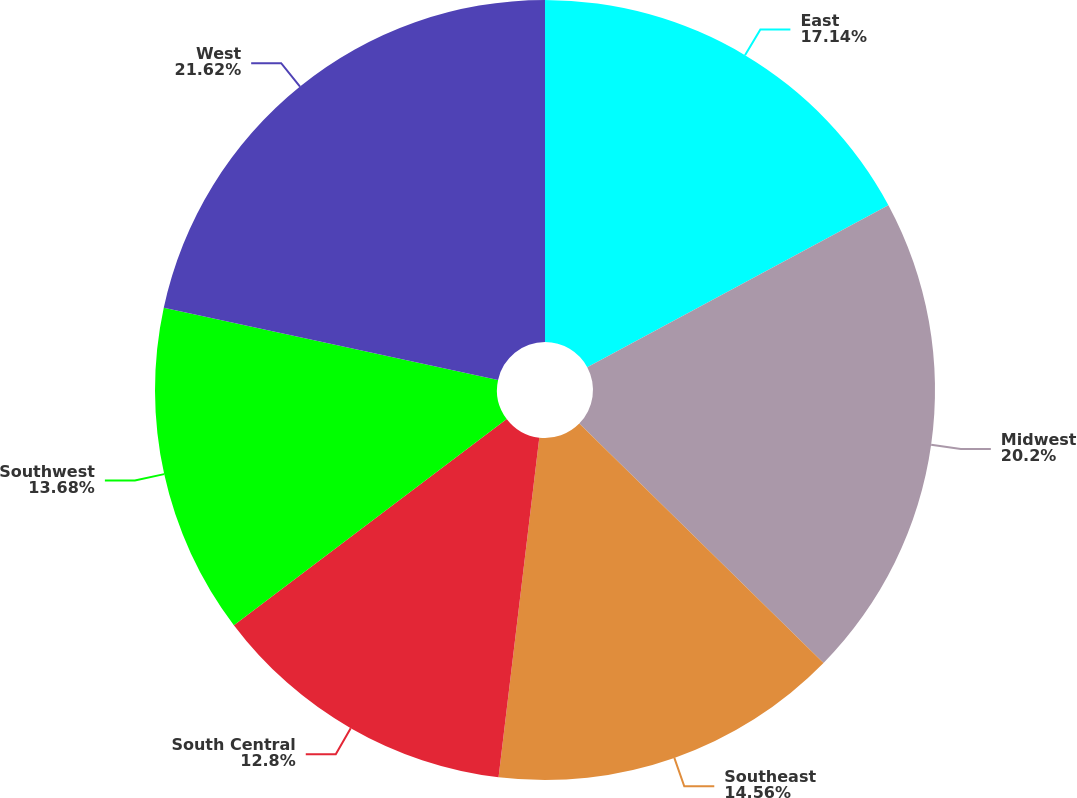Convert chart. <chart><loc_0><loc_0><loc_500><loc_500><pie_chart><fcel>East<fcel>Midwest<fcel>Southeast<fcel>South Central<fcel>Southwest<fcel>West<nl><fcel>17.14%<fcel>20.2%<fcel>14.56%<fcel>12.8%<fcel>13.68%<fcel>21.62%<nl></chart> 